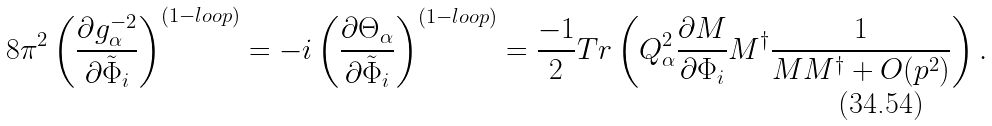<formula> <loc_0><loc_0><loc_500><loc_500>8 { \pi } ^ { 2 } \left ( \frac { \partial { g _ { \alpha } ^ { - 2 } } } { \partial { \tilde { \Phi } } _ { i } } \right ) ^ { ( 1 - l o o p ) } = - i \left ( \frac { \partial \Theta _ { \alpha } } { \partial { \tilde { \Phi } } _ { i } } \right ) ^ { ( 1 - l o o p ) } = \frac { - 1 } { 2 } T r \left ( Q _ { \alpha } ^ { 2 } \frac { \partial M } { \partial { \Phi } _ { i } } M ^ { \dagger } \frac { 1 } { M M ^ { \dagger } + O ( p ^ { 2 } ) } \right ) .</formula> 